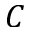Convert formula to latex. <formula><loc_0><loc_0><loc_500><loc_500>C</formula> 